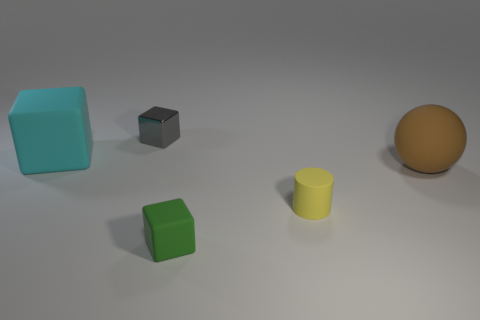There is a small cylinder; how many objects are to the right of it?
Provide a succinct answer. 1. Is there any other thing that has the same material as the tiny gray cube?
Make the answer very short. No. There is a object on the right side of the small rubber cylinder; is its shape the same as the cyan object?
Keep it short and to the point. No. There is a large matte object to the left of the gray metallic cube; what color is it?
Ensure brevity in your answer.  Cyan. What is the shape of the small green thing that is made of the same material as the big cyan block?
Offer a very short reply. Cube. Is there any other thing that has the same color as the sphere?
Give a very brief answer. No. Is the number of big matte things to the left of the matte cylinder greater than the number of small yellow rubber cylinders behind the gray cube?
Provide a succinct answer. Yes. What number of balls are the same size as the green thing?
Keep it short and to the point. 0. Are there fewer tiny cubes behind the big cyan matte thing than spheres that are left of the brown ball?
Give a very brief answer. No. Are there any gray metal things of the same shape as the big cyan rubber thing?
Offer a very short reply. Yes. 